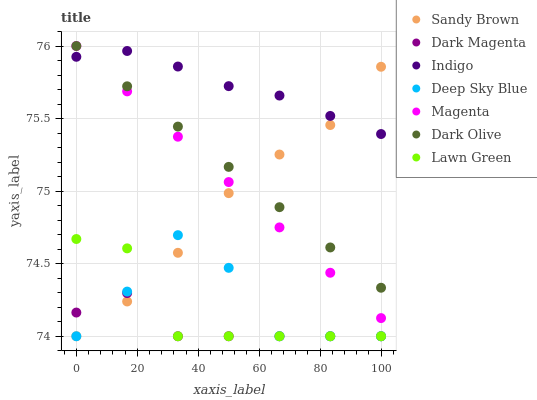Does Dark Magenta have the minimum area under the curve?
Answer yes or no. Yes. Does Indigo have the maximum area under the curve?
Answer yes or no. Yes. Does Indigo have the minimum area under the curve?
Answer yes or no. No. Does Dark Magenta have the maximum area under the curve?
Answer yes or no. No. Is Dark Olive the smoothest?
Answer yes or no. Yes. Is Deep Sky Blue the roughest?
Answer yes or no. Yes. Is Indigo the smoothest?
Answer yes or no. No. Is Indigo the roughest?
Answer yes or no. No. Does Lawn Green have the lowest value?
Answer yes or no. Yes. Does Indigo have the lowest value?
Answer yes or no. No. Does Magenta have the highest value?
Answer yes or no. Yes. Does Indigo have the highest value?
Answer yes or no. No. Is Deep Sky Blue less than Indigo?
Answer yes or no. Yes. Is Magenta greater than Deep Sky Blue?
Answer yes or no. Yes. Does Deep Sky Blue intersect Lawn Green?
Answer yes or no. Yes. Is Deep Sky Blue less than Lawn Green?
Answer yes or no. No. Is Deep Sky Blue greater than Lawn Green?
Answer yes or no. No. Does Deep Sky Blue intersect Indigo?
Answer yes or no. No. 